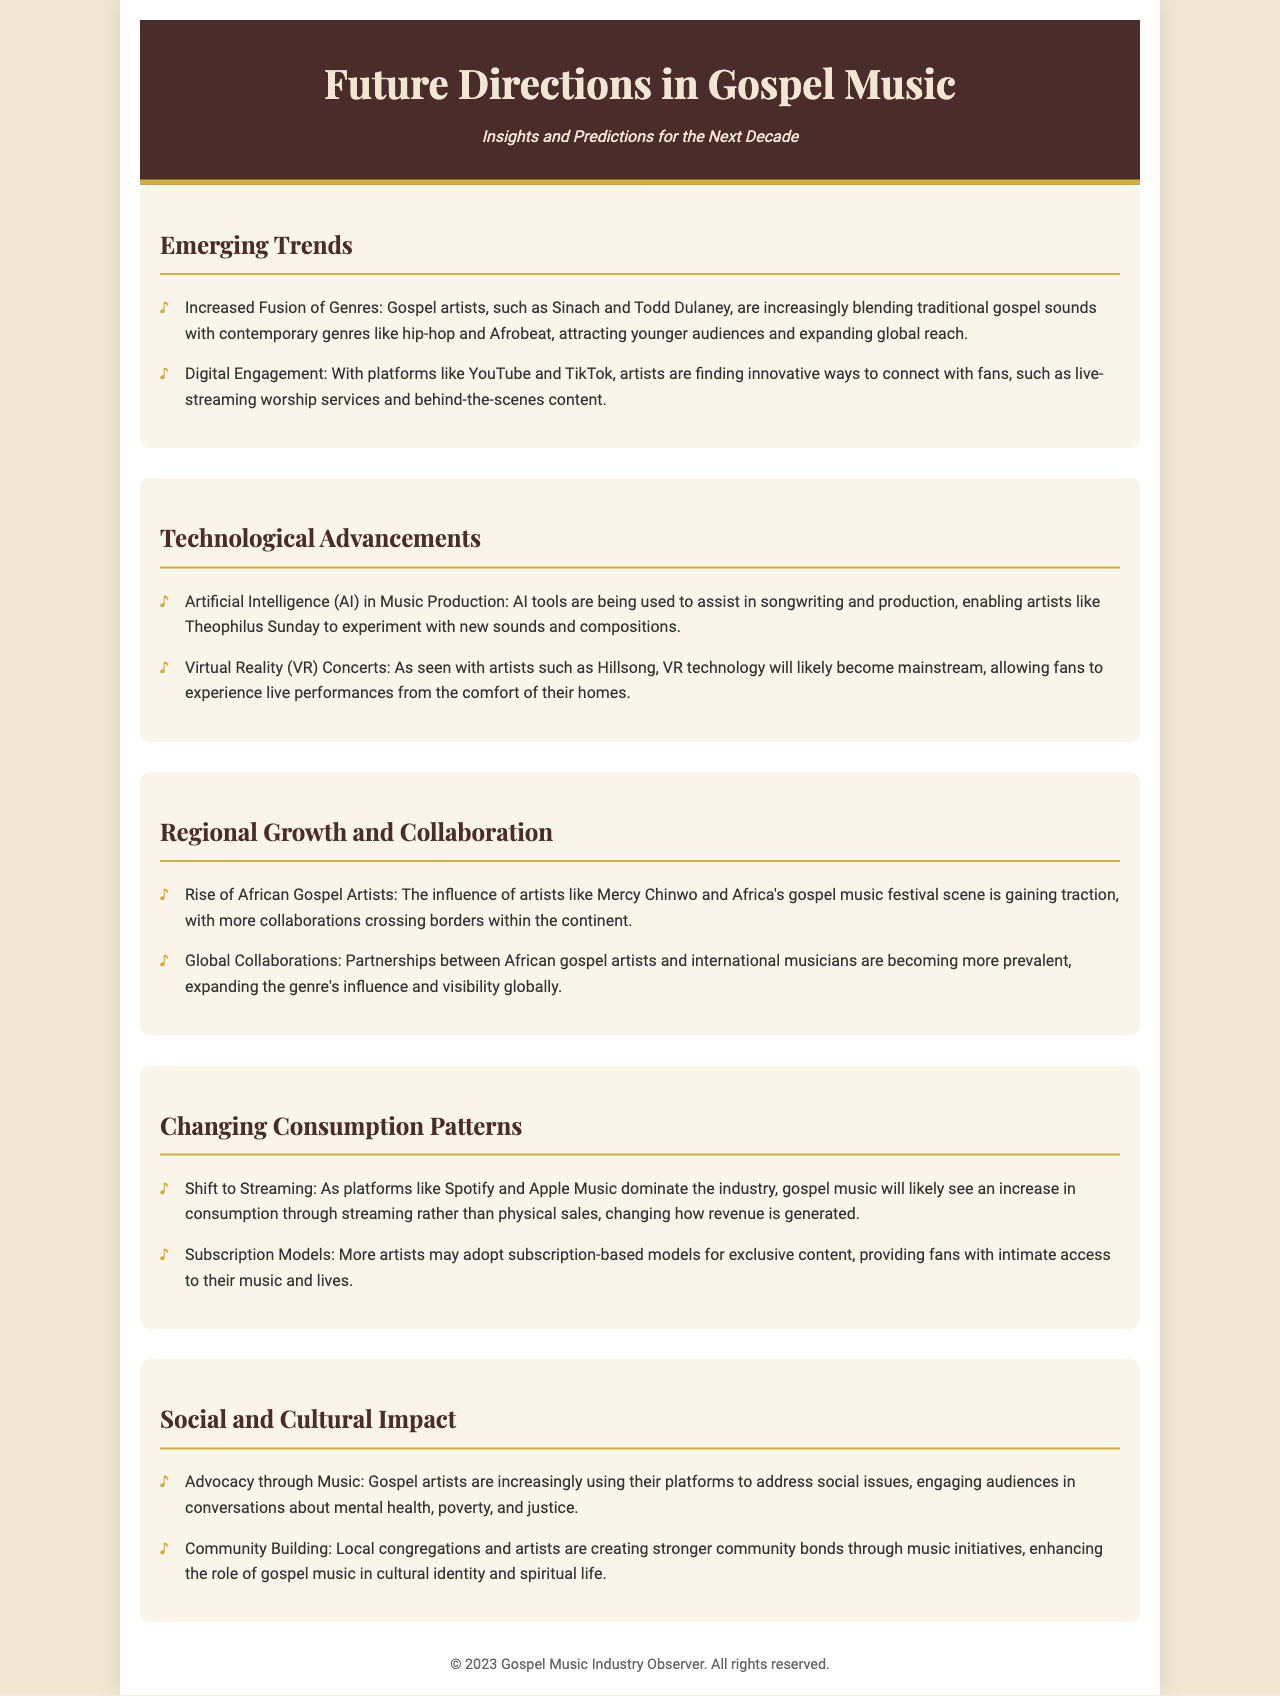what is the title of the document? The title of the document is prominently displayed in the header section.
Answer: Future Directions in Gospel Music who are two gospel artists mentioned for blending genres? The document lists specific artists who are blending traditional gospel with contemporary genres.
Answer: Sinach and Todd Dulaney what technology is expected to become mainstream for concerts? The document discusses a specific emerging technology that is going to shape the experience of live performances in the future.
Answer: Virtual Reality (VR) Concerts what is a major trend in music consumption noted in the brochure? The document highlights a significant shift in how music is consumed and enjoyed by audiences.
Answer: Shift to Streaming which artist is mentioned as using AI tools in music production? The document identifies a specific artist known for utilizing advanced technology in their music creation process.
Answer: Theophilus Sunday how are local communities engaging with gospel music according to the document? The document explains how gospel music is fostering interactions and relationships within communities.
Answer: Community Building what type of models may artists adopt for exclusive content? The document suggests a specific business model that may be increasingly utilized by artists to connect with fans.
Answer: Subscription Models what social issues are gospel artists addressing through their music? The document outlines various societal topics that are becoming prominent themes in gospel music.
Answer: Mental health, poverty, and justice who is an example of a rising African gospel artist mentioned? The document provides specific names to exemplify the growth of African gospel artists.
Answer: Mercy Chinwo 